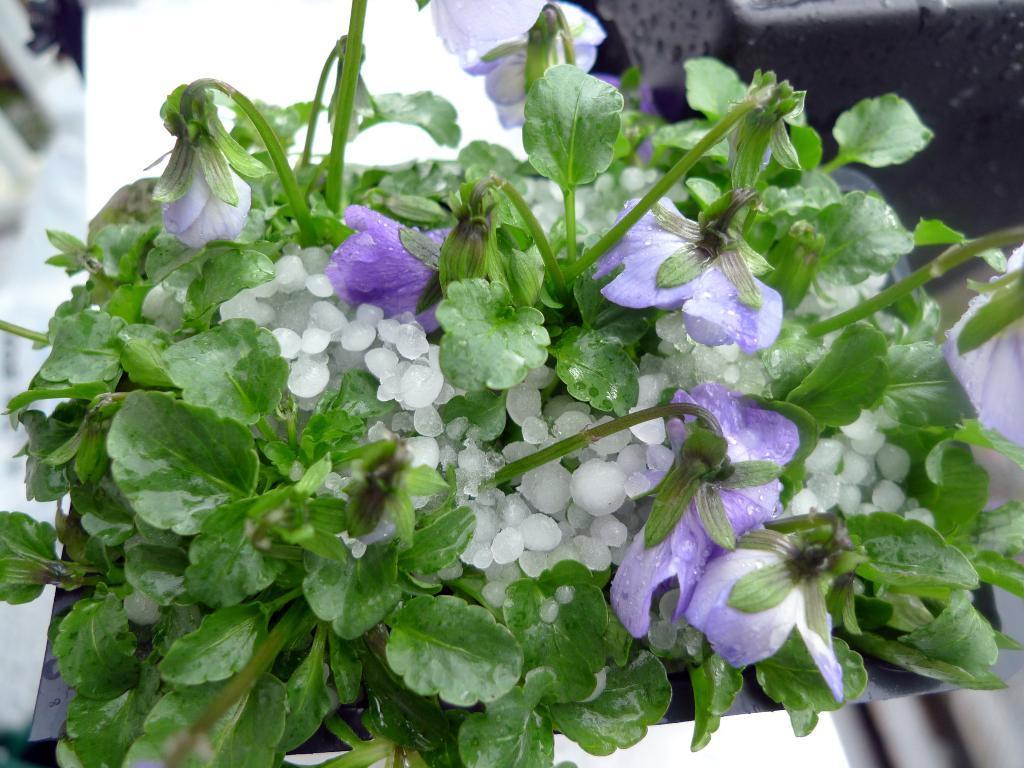In one or two sentences, can you explain what this image depicts? In the picture I can see violet color flowers of a plant. Here I can see some white color objects and the background of the image is blurred. 